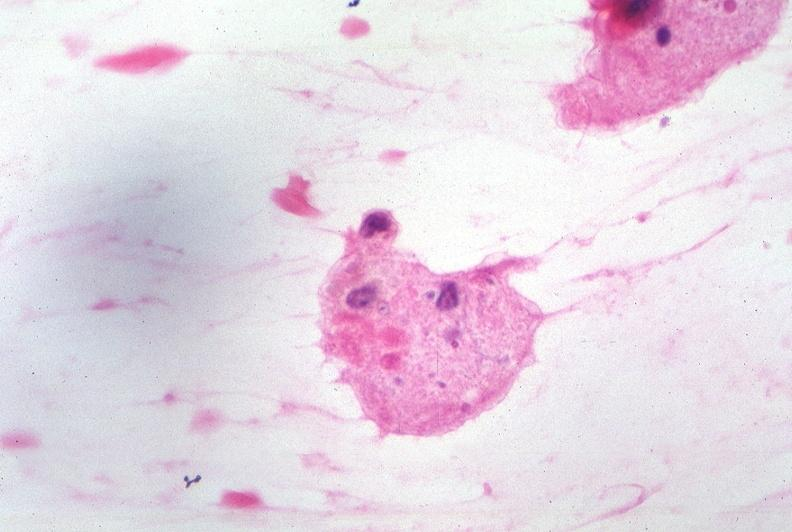does peritoneum show touch impression from cerebrospinal fluid - toxoplasma?
Answer the question using a single word or phrase. No 